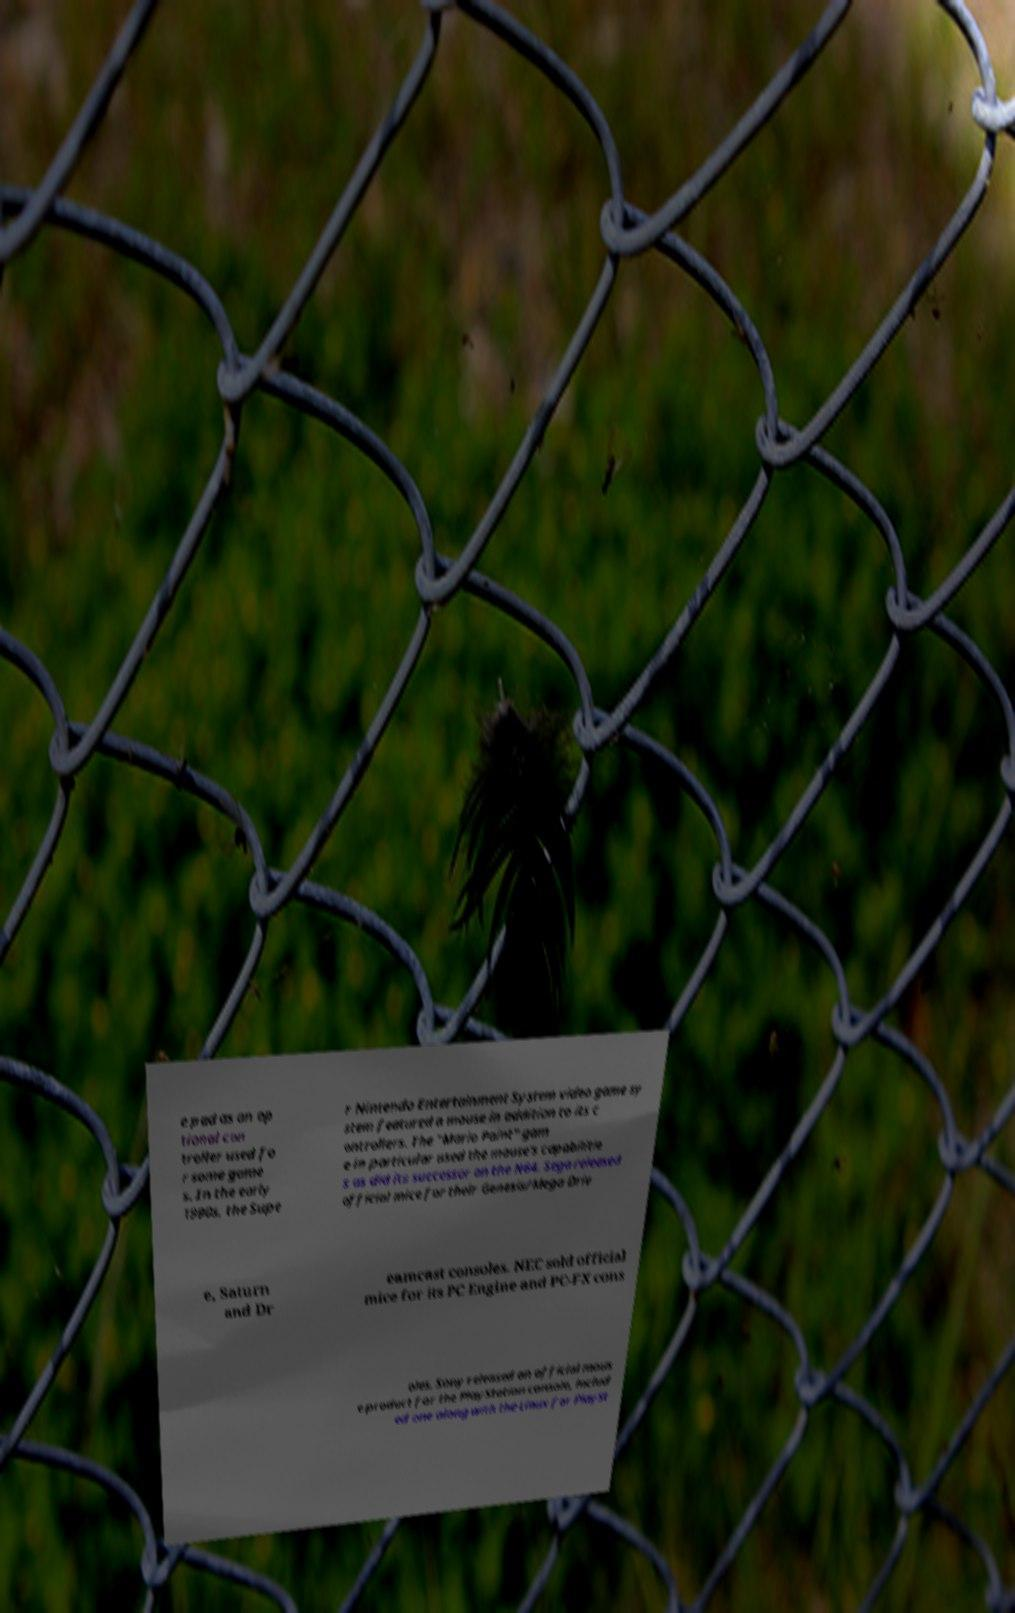Could you assist in decoding the text presented in this image and type it out clearly? e pad as an op tional con troller used fo r some game s. In the early 1990s, the Supe r Nintendo Entertainment System video game sy stem featured a mouse in addition to its c ontrollers. The "Mario Paint" gam e in particular used the mouse's capabilitie s as did its successor on the N64. Sega released official mice for their Genesis/Mega Driv e, Saturn and Dr eamcast consoles. NEC sold official mice for its PC Engine and PC-FX cons oles. Sony released an official mous e product for the PlayStation console, includ ed one along with the Linux for PlaySt 